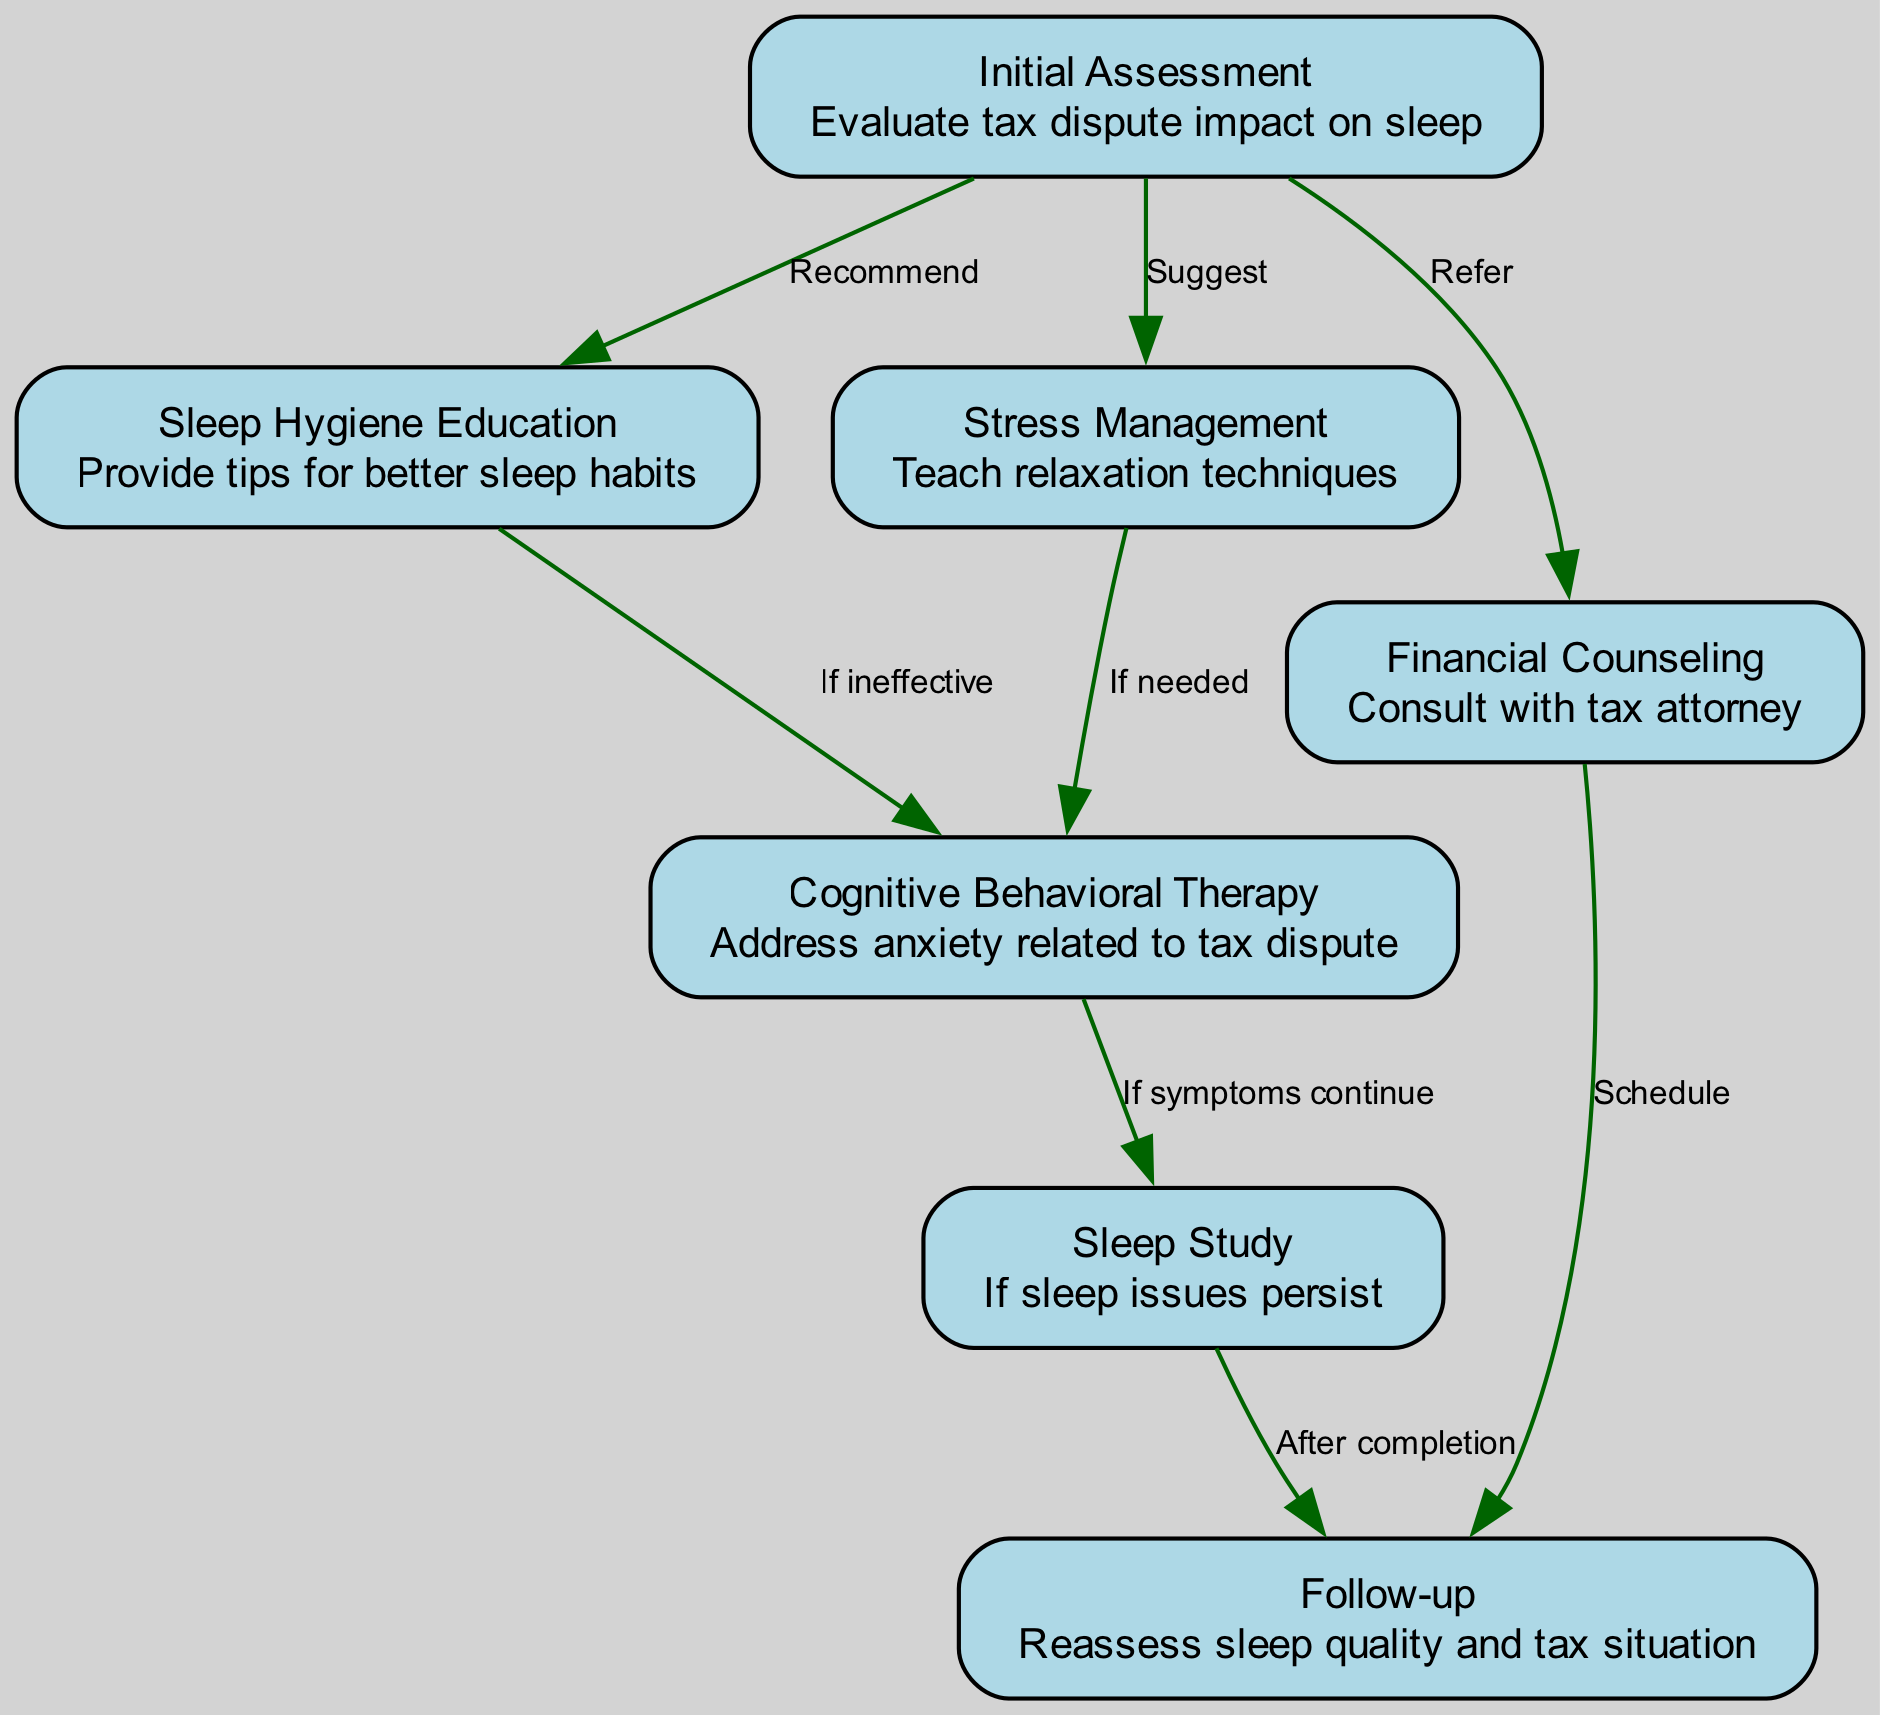What is the first step in the pathway? The first step in the pathway is depicted as "Initial Assessment," which evaluates the tax dispute's impact on sleep.
Answer: Initial Assessment How many nodes are present in the diagram? By counting all distinct nodes listed in the data, there are 7 nodes in total representing different steps in the care plan.
Answer: 7 What do you do after "Stress Management"? "Cognitive Behavioral Therapy" is the follow-up step after "Stress Management," specifically if needed based on the stress management outcomes.
Answer: Cognitive Behavioral Therapy What is recommended after "Initial Assessment"? Following "Initial Assessment," "Sleep Hygiene Education" is recommended to provide tips for better sleep habits.
Answer: Sleep Hygiene Education What is the outcome after “Cognitive Behavioral Therapy” if symptoms continue? If symptoms persist after the "Cognitive Behavioral Therapy," the next step is to undergo a "Sleep Study" for further evaluation.
Answer: Sleep Study Which step is linked to "Financial Counseling"? "Follow-up" is linked to "Financial Counseling," scheduled after consulting with a tax attorney to address financial issues related to the tax dispute.
Answer: Follow-up How many edges are in the diagram? By reviewing the connections between the nodes, there are a total of 8 edges that illustrate the relationships between the steps.
Answer: 8 What must occur after completion of the "Sleep Study"? After completing the "Sleep Study," a "Follow-up" must occur to reassess the sleep quality and tax situation.
Answer: Follow-up 